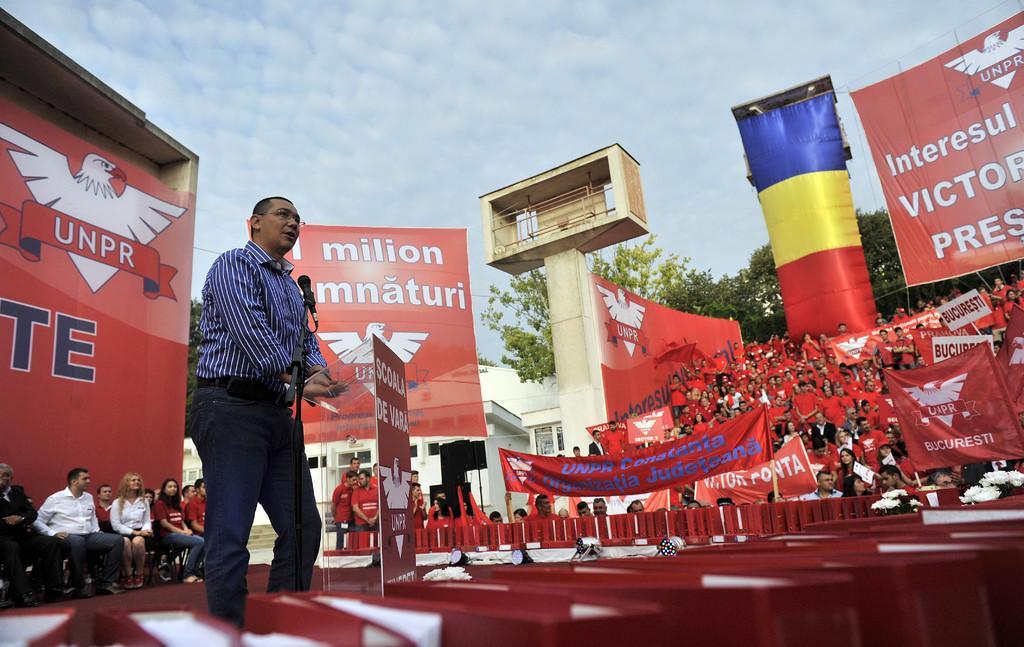Please provide a concise description of this image. On the left a man is standing on the stage at the podium and there is a mic on a stand. In the background there are few persons sitting on the chairs and few are standing and we can see hoardings,banners,poles,buildings,windows,trees and clouds in the sky. 